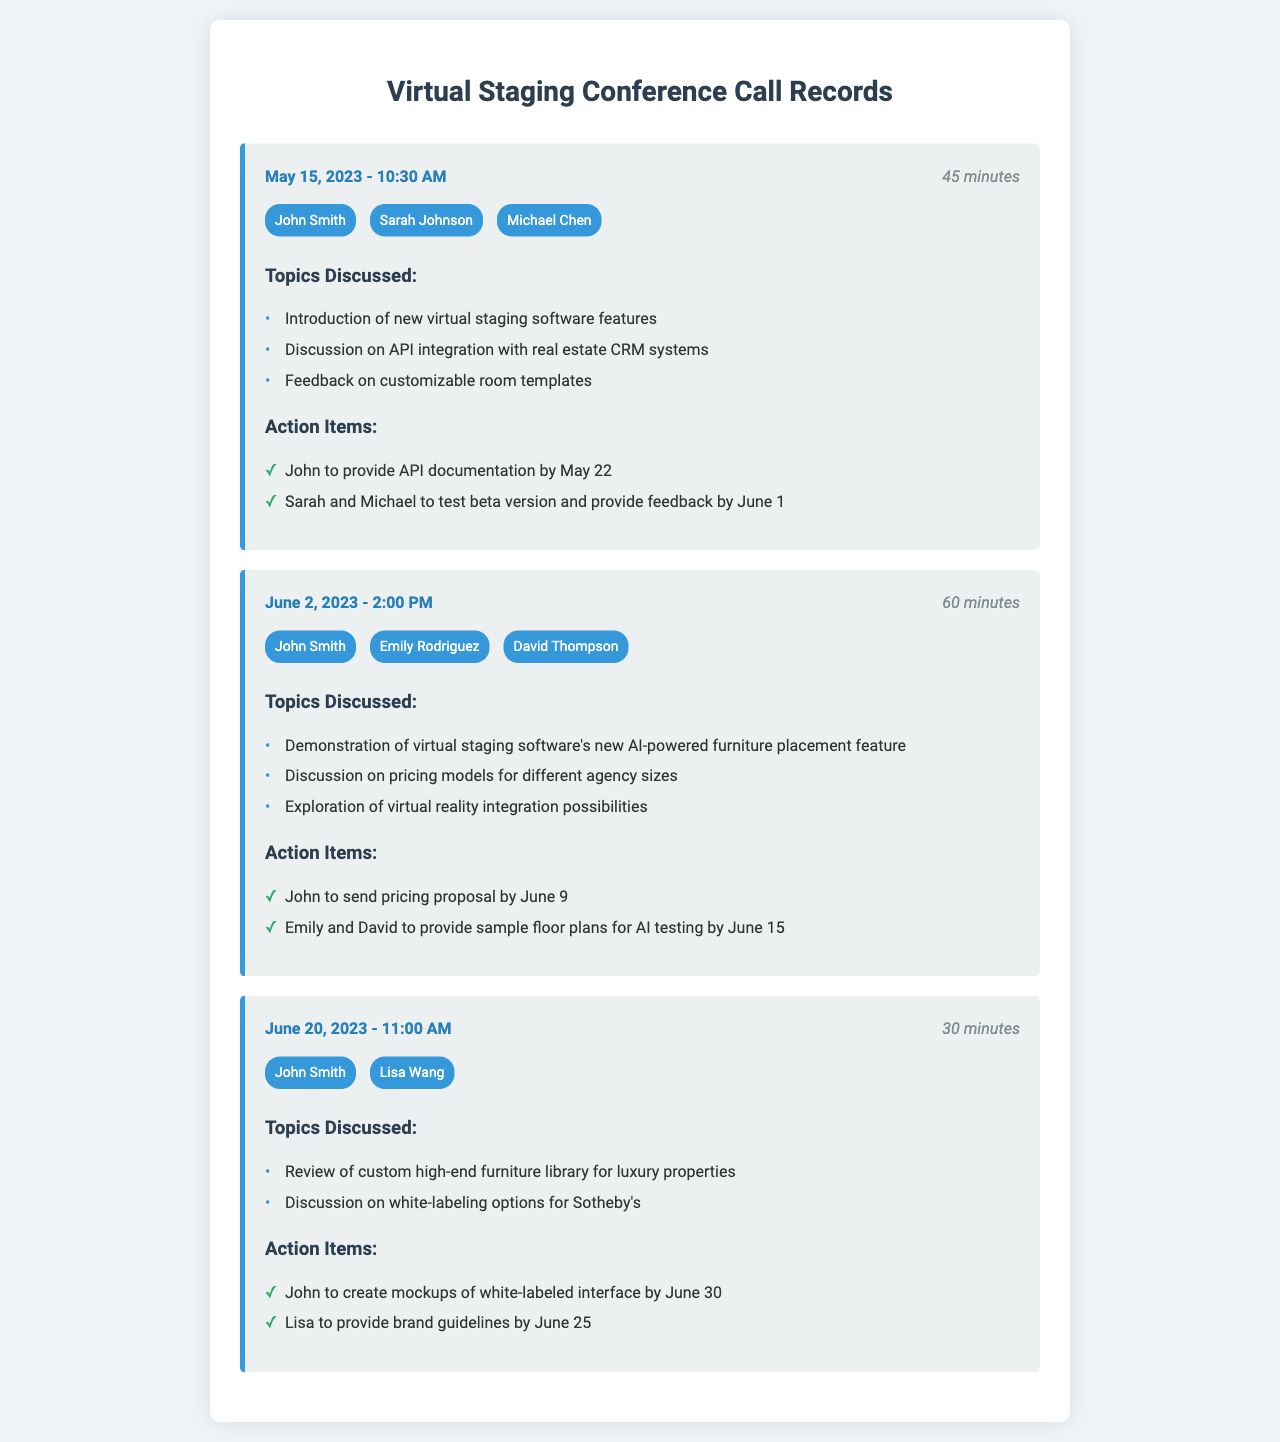What date was the first conference call? The first conference call recorded took place on May 15, 2023.
Answer: May 15, 2023 Who provided feedback on customizable room templates? Sarah Johnson was one of the participants discussing feedback on customizable room templates during the first call.
Answer: Sarah Johnson How long was the second conference call? The duration of the second conference call was documented to be 60 minutes.
Answer: 60 minutes What action item was assigned to Emily Rodriguez? Emily Rodriguez was tasked with providing sample floor plans for AI testing by June 15.
Answer: Provide sample floor plans for AI testing by June 15 Which feature was demonstrated during the second conference call? The new AI-powered furniture placement feature of the virtual staging software was demonstrated in the second call.
Answer: AI-powered furniture placement feature How many participants attended the call on June 20, 2023? The call on June 20, 2023, had two participants: John Smith and Lisa Wang.
Answer: Two What is the purpose of the call records document? The document serves as a record of conference calls discussing virtual staging integration for real estate purposes.
Answer: Conference calls discussing virtual staging integration What action item was requested by Lisa Wang? Lisa Wang was asked to provide brand guidelines by June 25.
Answer: Provide brand guidelines by June 25 Which topic was discussed regarding Sotheby's? The discussion included white-labeling options specifically for Sotheby's during the June 20 call.
Answer: White-labeling options for Sotheby's 